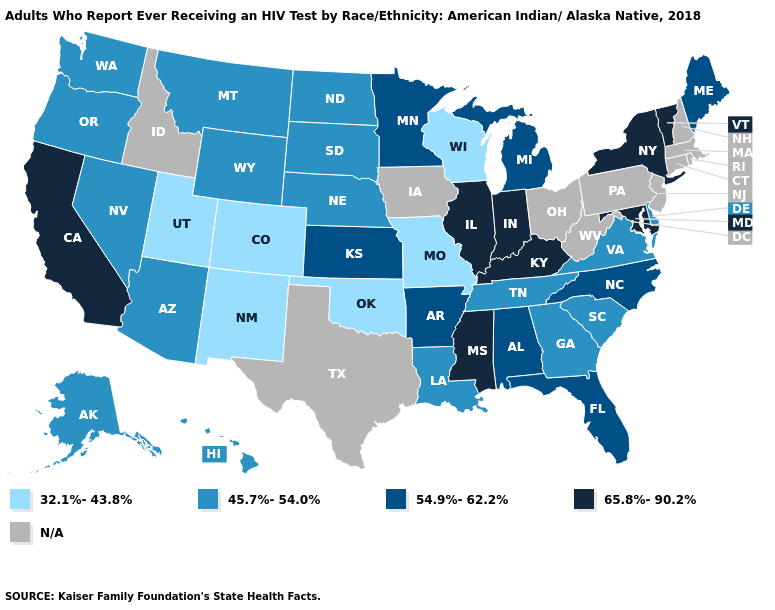What is the highest value in states that border Florida?
Quick response, please. 54.9%-62.2%. Among the states that border Mississippi , does Louisiana have the lowest value?
Concise answer only. Yes. What is the value of Minnesota?
Write a very short answer. 54.9%-62.2%. Name the states that have a value in the range 45.7%-54.0%?
Quick response, please. Alaska, Arizona, Delaware, Georgia, Hawaii, Louisiana, Montana, Nebraska, Nevada, North Dakota, Oregon, South Carolina, South Dakota, Tennessee, Virginia, Washington, Wyoming. Name the states that have a value in the range 32.1%-43.8%?
Give a very brief answer. Colorado, Missouri, New Mexico, Oklahoma, Utah, Wisconsin. Name the states that have a value in the range 54.9%-62.2%?
Write a very short answer. Alabama, Arkansas, Florida, Kansas, Maine, Michigan, Minnesota, North Carolina. Name the states that have a value in the range 32.1%-43.8%?
Give a very brief answer. Colorado, Missouri, New Mexico, Oklahoma, Utah, Wisconsin. What is the highest value in the MidWest ?
Write a very short answer. 65.8%-90.2%. Name the states that have a value in the range 54.9%-62.2%?
Be succinct. Alabama, Arkansas, Florida, Kansas, Maine, Michigan, Minnesota, North Carolina. Among the states that border Louisiana , which have the highest value?
Quick response, please. Mississippi. What is the value of Pennsylvania?
Short answer required. N/A. What is the value of Oklahoma?
Answer briefly. 32.1%-43.8%. Does Indiana have the highest value in the USA?
Short answer required. Yes. Name the states that have a value in the range 54.9%-62.2%?
Be succinct. Alabama, Arkansas, Florida, Kansas, Maine, Michigan, Minnesota, North Carolina. 